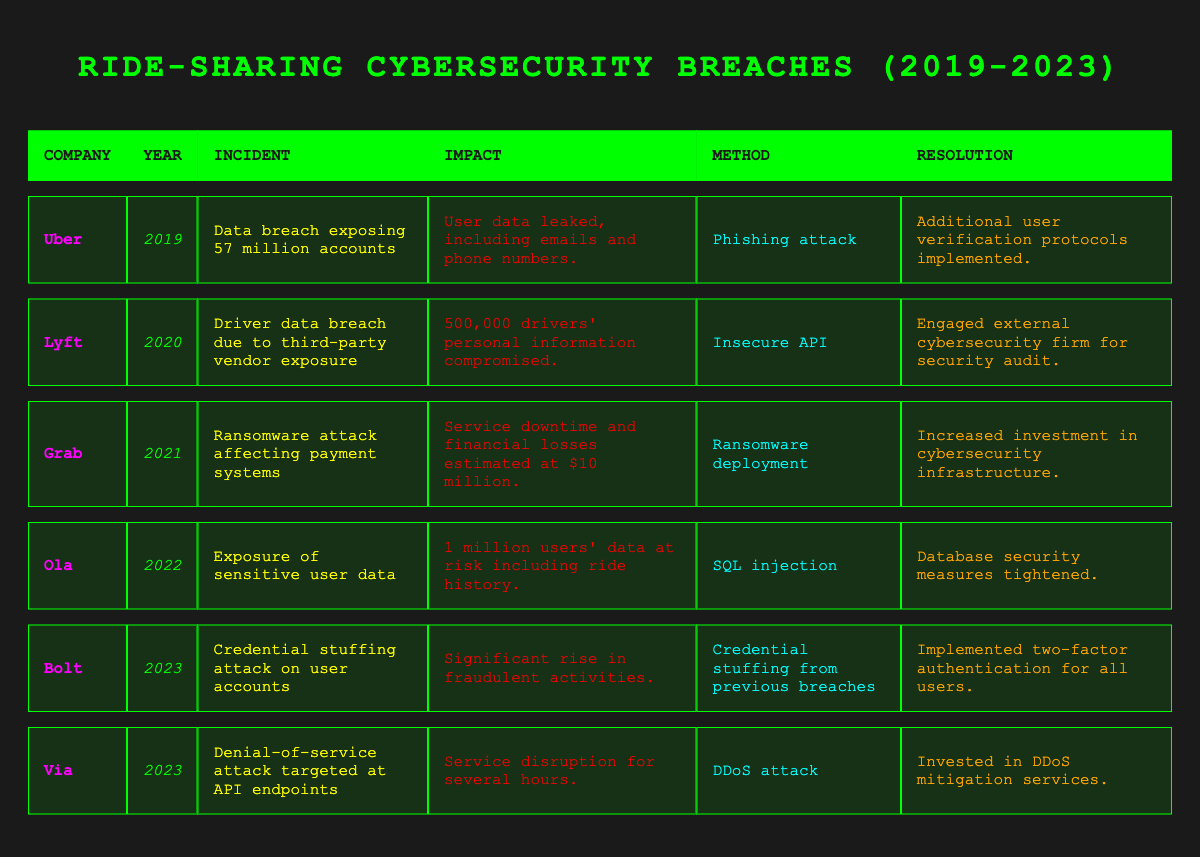What year did Uber experience a data breach? The table shows Uber had a data breach in the year 2019.
Answer: 2019 What was the incident reported by Lyft in 2020? According to the table, Lyft's incident in 2020 was a driver data breach due to third-party vendor exposure.
Answer: Driver data breach due to third-party vendor exposure How many users were affected by Ola's incident in 2022? The table indicates that 1 million users' data was at risk in Ola's incident in 2022.
Answer: 1 million Is there an incident involving a denial-of-service attack in the data? Yes, the table lists Via experiencing a denial-of-service attack targeted at API endpoints in 2023.
Answer: Yes Which ride-sharing company experienced a ransomware attack and when? The table states that Grab experienced a ransomware attack in 2021.
Answer: Grab in 2021 What was the estimated financial loss from Grab's incident? The table indicates that Grab's service downtime caused financial losses estimated at $10 million.
Answer: $10 million Did any of the companies implement two-factor authentication after their breaches? Yes, Bolt implemented two-factor authentication for all users after a credential stuffing attack in 2023.
Answer: Yes Which company had the largest number of user accounts breached, and how many? Uber had the largest breach, exposing 57 million accounts in 2019.
Answer: Uber, 57 million Which cybersecurity breach method was used in Ola's case? The table specifies that Ola's incident was due to an SQL injection.
Answer: SQL injection In which year did the most recent breach occur according to the table? The latest breaches occurred in 2023, as indicated by the incidents involving Bolt and Via.
Answer: 2023 Which company experienced a phishing attack, and what was the resolution? Uber was affected by a phishing attack, and the resolution was to implement additional user verification protocols.
Answer: Uber, additional user verification protocols implemented How many different companies were involved in breaches over the 5-year period? From the table, there are 6 different companies listed as involved in breaches between 2019 and 2023.
Answer: 6 What can we discern about the trend in cybersecurity incidents from this data? The table shows that incidents continue to occur, with the most recent breaches in 2023 and methods evolving; indicating ongoing cybersecurity challenges in the ride-sharing industry.
Answer: Ongoing cybersecurity challenges What percentage of incidents in the table involved sensitive user data exposure? Out of 6 incidents, 4 involved sensitive user data exposure, leading to 66.67%. (4/6)*100 = 66.67%
Answer: 66.67% 